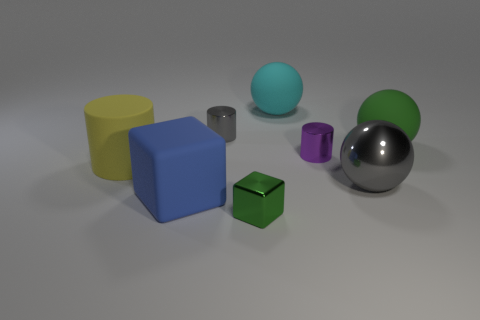Subtract 1 cylinders. How many cylinders are left? 2 Subtract all large rubber balls. How many balls are left? 1 Add 1 tiny red rubber objects. How many objects exist? 9 Subtract all cylinders. How many objects are left? 5 Subtract 1 gray spheres. How many objects are left? 7 Subtract all large green shiny balls. Subtract all cyan rubber objects. How many objects are left? 7 Add 2 large shiny spheres. How many large shiny spheres are left? 3 Add 7 big red blocks. How many big red blocks exist? 7 